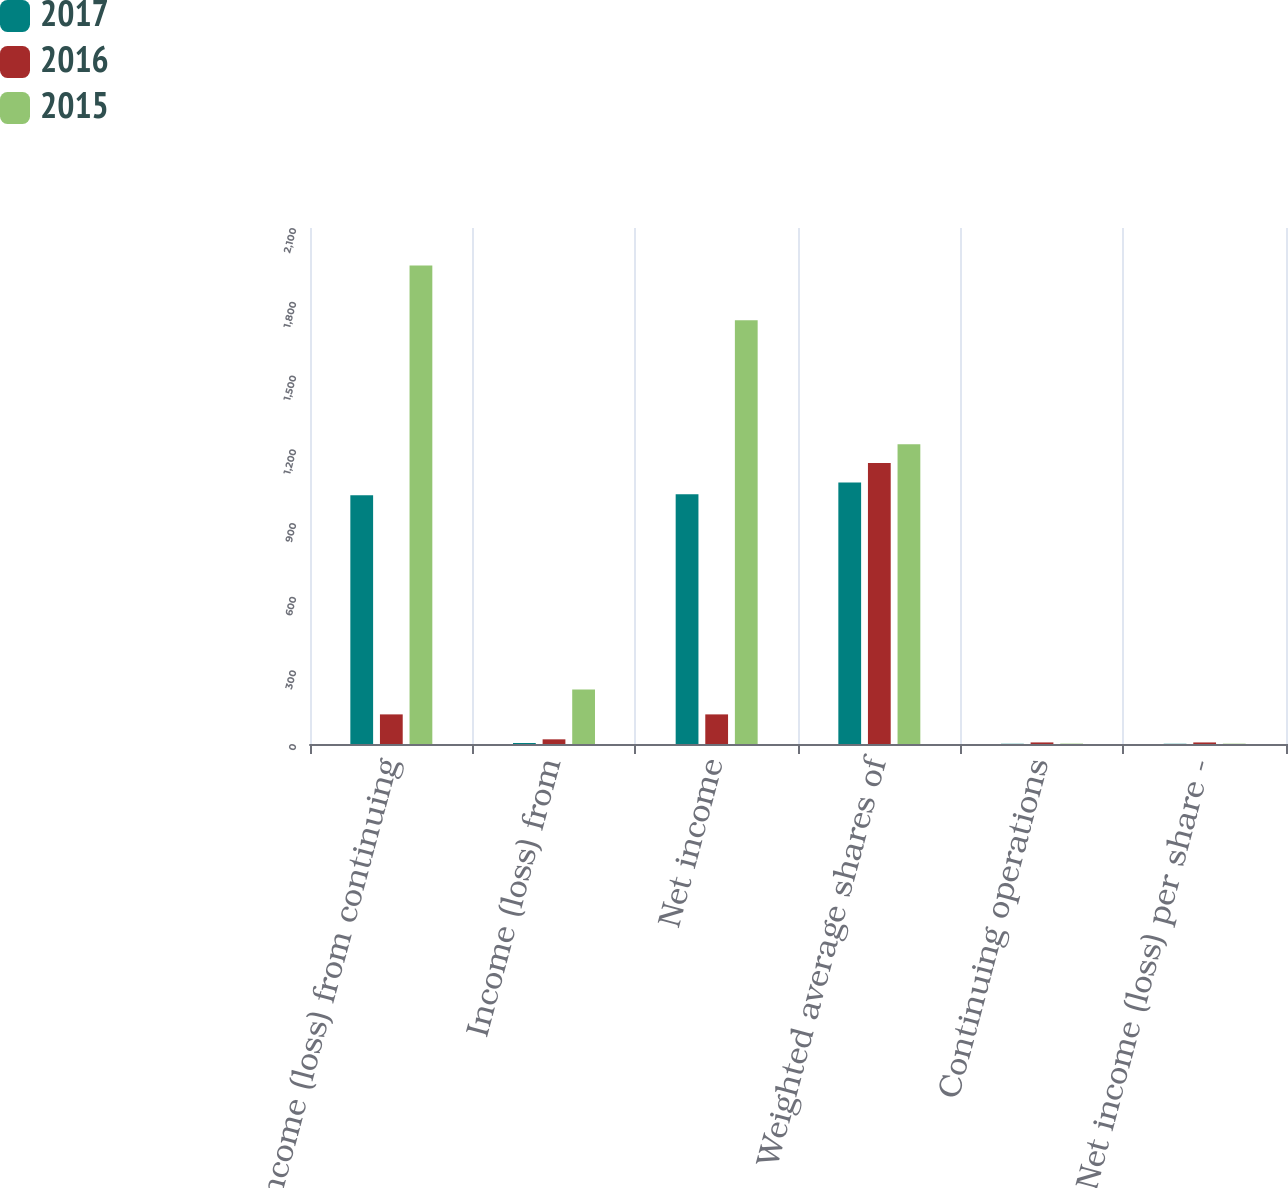Convert chart. <chart><loc_0><loc_0><loc_500><loc_500><stacked_bar_chart><ecel><fcel>Income (loss) from continuing<fcel>Income (loss) from<fcel>Net income<fcel>Weighted average shares of<fcel>Continuing operations<fcel>Net income (loss) per share -<nl><fcel>2017<fcel>1012<fcel>4<fcel>1016<fcel>1064<fcel>0.95<fcel>0.95<nl><fcel>2016<fcel>120.5<fcel>19<fcel>120.5<fcel>1144<fcel>6.43<fcel>6.35<nl><fcel>2015<fcel>1947<fcel>222<fcel>1725<fcel>1220<fcel>1.61<fcel>1.42<nl></chart> 